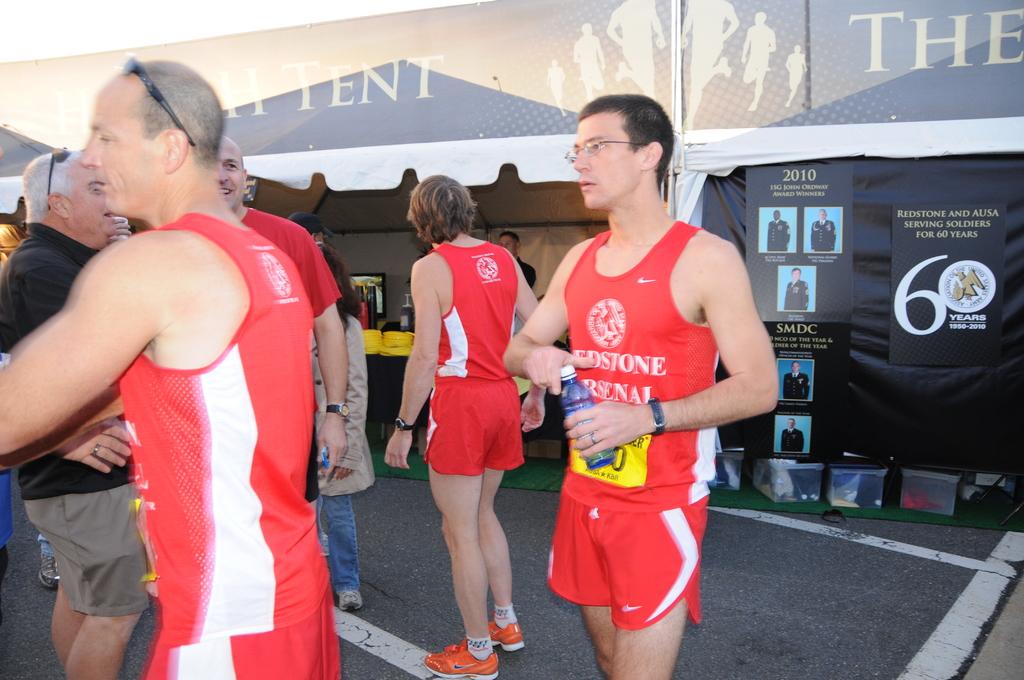How long have redstone and alisa been serving soldiers?
Your answer should be very brief. 60 years. What year are the photos in the back from?
Ensure brevity in your answer.  2010. 